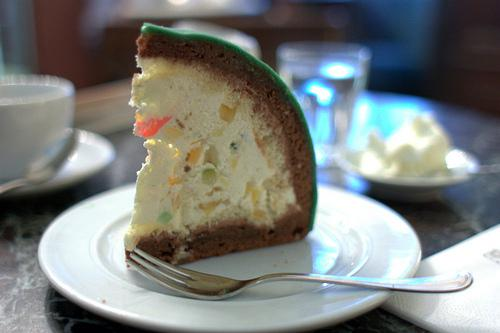Question: what is in the picture?
Choices:
A. Cake.
B. A dog.
C. A house.
D. A train.
Answer with the letter. Answer: A Question: where is the Plate?
Choices:
A. On the counter.
B. On the stove.
C. In the waiters hand.
D. On a restaurant table.
Answer with the letter. Answer: D Question: why is the cake on the table?
Choices:
A. It is a birthday.
B. For coffee time.
C. It is a wedding.
D. To celebrate.
Answer with the letter. Answer: B Question: what is next to the cake?
Choices:
A. A knife.
B. Punch.
C. Plates.
D. A fork.
Answer with the letter. Answer: D 